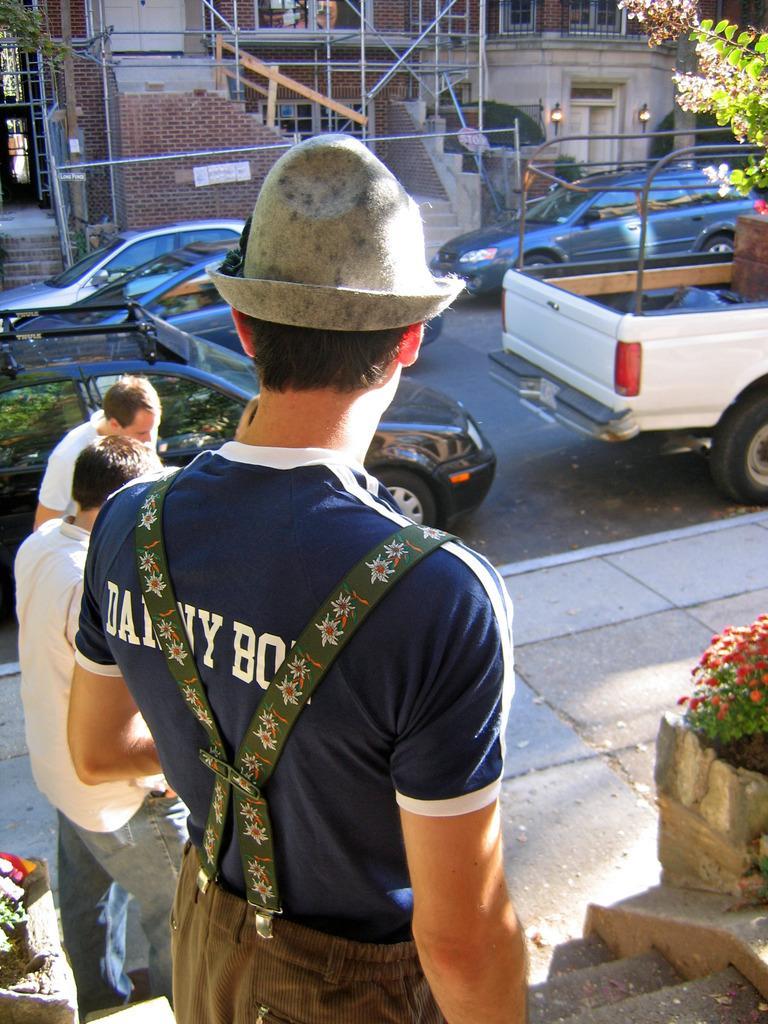In one or two sentences, can you explain what this image depicts? In this image we can see three persons are standing, there are some plants and flowers. Few cars are parked on the road, there is a building, and a person is wearing a hat. 